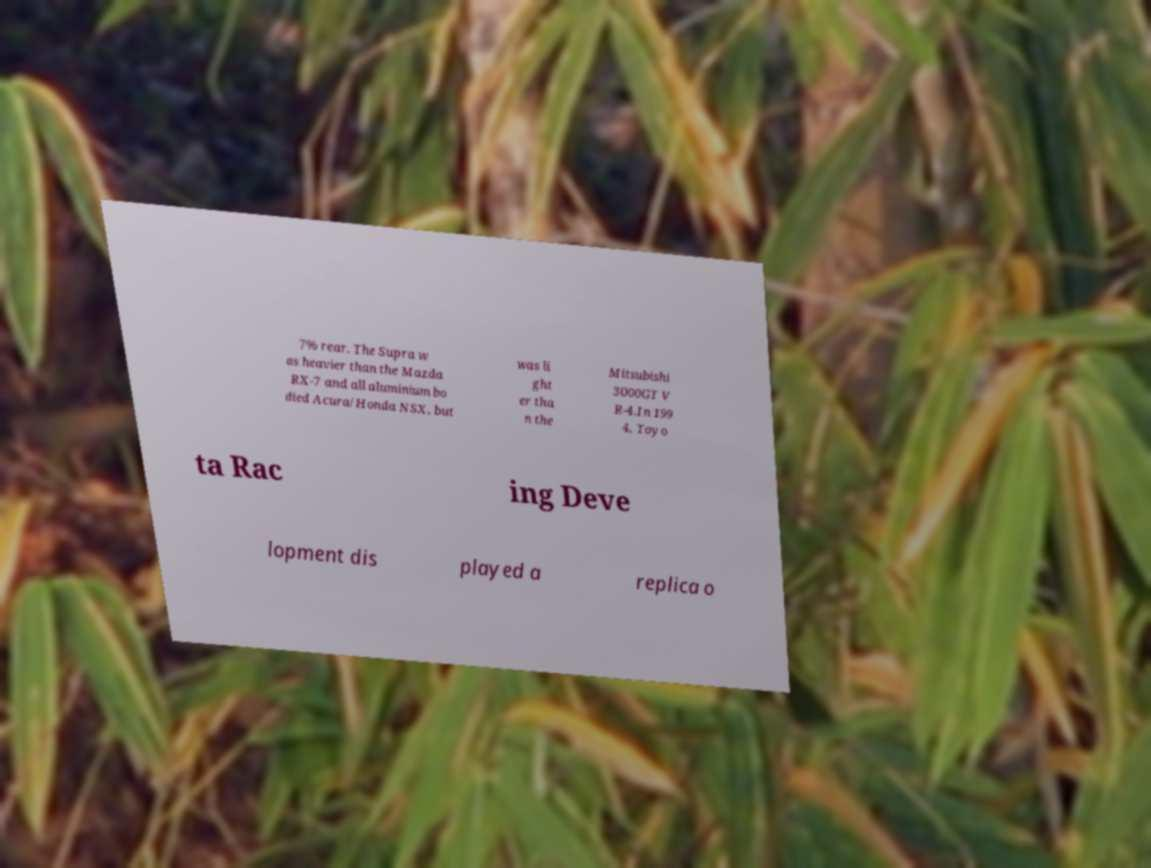Can you accurately transcribe the text from the provided image for me? 7% rear. The Supra w as heavier than the Mazda RX-7 and all aluminium bo died Acura/Honda NSX, but was li ght er tha n the Mitsubishi 3000GT V R-4.In 199 4, Toyo ta Rac ing Deve lopment dis played a replica o 